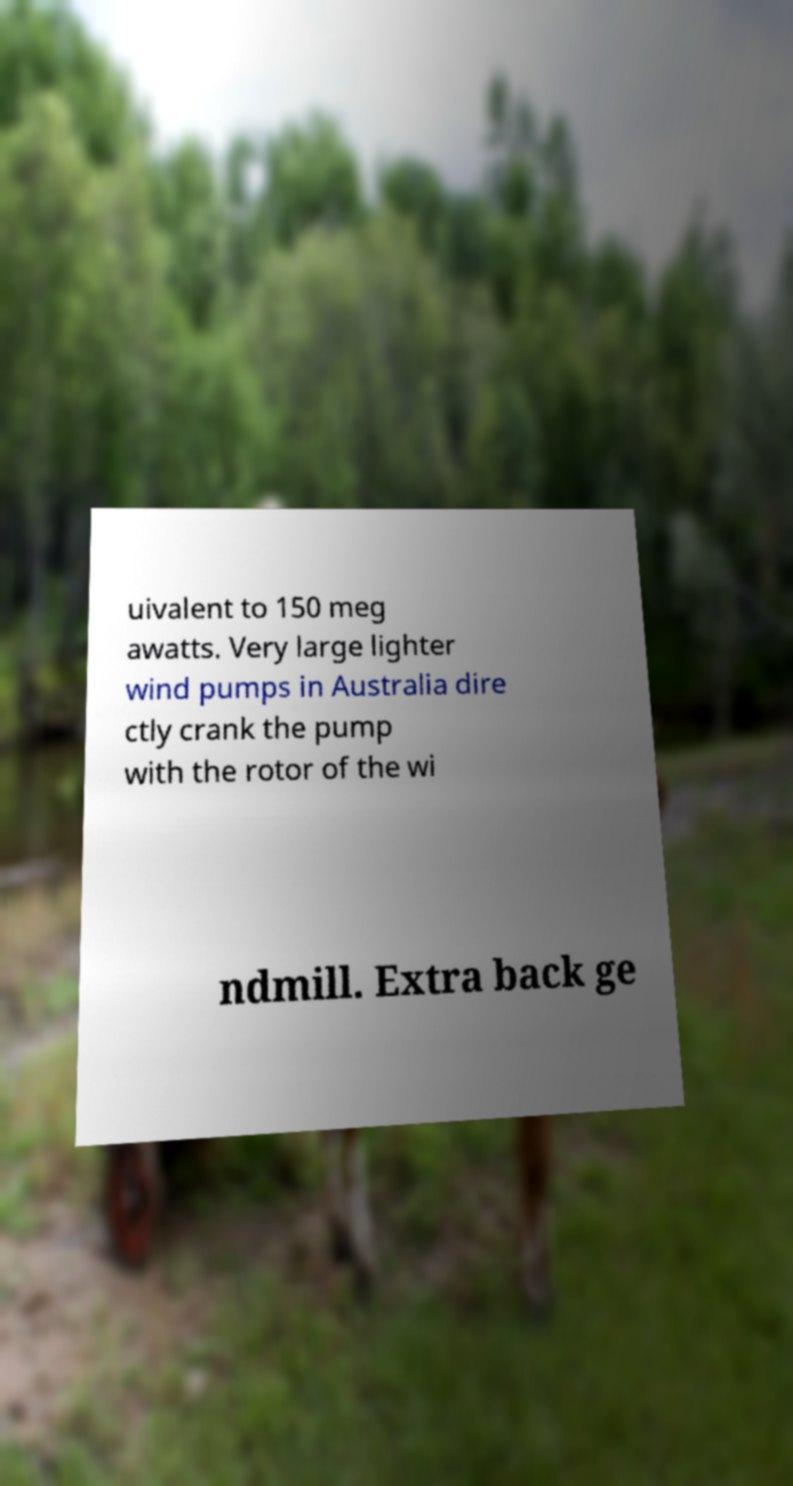Can you accurately transcribe the text from the provided image for me? uivalent to 150 meg awatts. Very large lighter wind pumps in Australia dire ctly crank the pump with the rotor of the wi ndmill. Extra back ge 